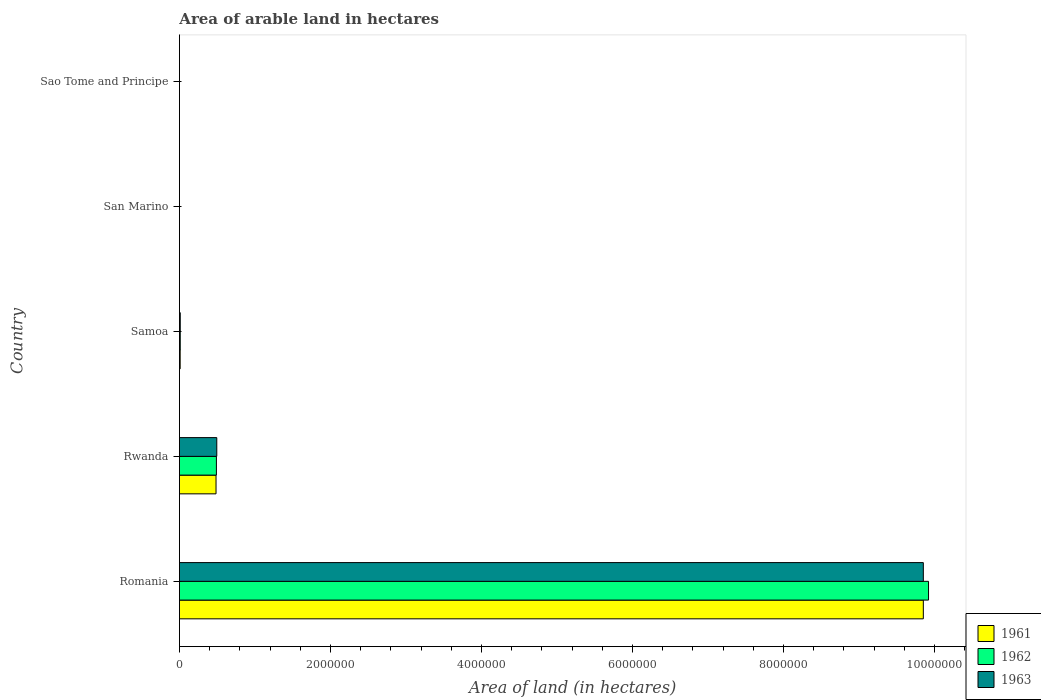Are the number of bars per tick equal to the number of legend labels?
Provide a succinct answer. Yes. How many bars are there on the 3rd tick from the top?
Your answer should be very brief. 3. What is the label of the 3rd group of bars from the top?
Your answer should be very brief. Samoa. What is the total arable land in 1963 in Rwanda?
Make the answer very short. 4.95e+05. Across all countries, what is the maximum total arable land in 1961?
Offer a terse response. 9.85e+06. In which country was the total arable land in 1962 maximum?
Provide a short and direct response. Romania. In which country was the total arable land in 1963 minimum?
Your answer should be very brief. San Marino. What is the total total arable land in 1962 in the graph?
Your response must be concise. 1.04e+07. What is the difference between the total arable land in 1962 in Romania and that in Rwanda?
Offer a terse response. 9.43e+06. What is the difference between the total arable land in 1962 in Romania and the total arable land in 1963 in Rwanda?
Offer a very short reply. 9.43e+06. What is the average total arable land in 1963 per country?
Keep it short and to the point. 2.07e+06. What is the ratio of the total arable land in 1962 in Samoa to that in Sao Tome and Principe?
Offer a terse response. 11. What is the difference between the highest and the second highest total arable land in 1961?
Provide a short and direct response. 9.37e+06. What is the difference between the highest and the lowest total arable land in 1961?
Provide a short and direct response. 9.85e+06. In how many countries, is the total arable land in 1962 greater than the average total arable land in 1962 taken over all countries?
Give a very brief answer. 1. Is the sum of the total arable land in 1962 in Romania and Samoa greater than the maximum total arable land in 1961 across all countries?
Offer a very short reply. Yes. What does the 3rd bar from the bottom in Samoa represents?
Your answer should be compact. 1963. Are all the bars in the graph horizontal?
Your response must be concise. Yes. What is the difference between two consecutive major ticks on the X-axis?
Ensure brevity in your answer.  2.00e+06. Are the values on the major ticks of X-axis written in scientific E-notation?
Your answer should be very brief. No. Does the graph contain any zero values?
Offer a terse response. No. Where does the legend appear in the graph?
Provide a succinct answer. Bottom right. How many legend labels are there?
Your answer should be very brief. 3. What is the title of the graph?
Offer a very short reply. Area of arable land in hectares. Does "2002" appear as one of the legend labels in the graph?
Give a very brief answer. No. What is the label or title of the X-axis?
Make the answer very short. Area of land (in hectares). What is the label or title of the Y-axis?
Your response must be concise. Country. What is the Area of land (in hectares) in 1961 in Romania?
Keep it short and to the point. 9.85e+06. What is the Area of land (in hectares) of 1962 in Romania?
Your answer should be very brief. 9.92e+06. What is the Area of land (in hectares) in 1963 in Romania?
Your answer should be compact. 9.85e+06. What is the Area of land (in hectares) in 1961 in Rwanda?
Offer a very short reply. 4.85e+05. What is the Area of land (in hectares) in 1963 in Rwanda?
Your answer should be compact. 4.95e+05. What is the Area of land (in hectares) of 1962 in Samoa?
Ensure brevity in your answer.  1.10e+04. What is the Area of land (in hectares) in 1963 in Samoa?
Give a very brief answer. 1.10e+04. What is the Area of land (in hectares) of 1962 in San Marino?
Keep it short and to the point. 1000. What is the Area of land (in hectares) of 1963 in San Marino?
Offer a terse response. 1000. What is the Area of land (in hectares) in 1961 in Sao Tome and Principe?
Give a very brief answer. 1000. Across all countries, what is the maximum Area of land (in hectares) of 1961?
Offer a terse response. 9.85e+06. Across all countries, what is the maximum Area of land (in hectares) of 1962?
Your response must be concise. 9.92e+06. Across all countries, what is the maximum Area of land (in hectares) of 1963?
Offer a terse response. 9.85e+06. Across all countries, what is the minimum Area of land (in hectares) of 1961?
Provide a succinct answer. 1000. Across all countries, what is the minimum Area of land (in hectares) in 1963?
Offer a very short reply. 1000. What is the total Area of land (in hectares) in 1961 in the graph?
Your answer should be very brief. 1.04e+07. What is the total Area of land (in hectares) of 1962 in the graph?
Offer a very short reply. 1.04e+07. What is the total Area of land (in hectares) of 1963 in the graph?
Provide a succinct answer. 1.04e+07. What is the difference between the Area of land (in hectares) in 1961 in Romania and that in Rwanda?
Provide a succinct answer. 9.37e+06. What is the difference between the Area of land (in hectares) of 1962 in Romania and that in Rwanda?
Offer a very short reply. 9.43e+06. What is the difference between the Area of land (in hectares) in 1963 in Romania and that in Rwanda?
Offer a terse response. 9.36e+06. What is the difference between the Area of land (in hectares) of 1961 in Romania and that in Samoa?
Ensure brevity in your answer.  9.84e+06. What is the difference between the Area of land (in hectares) in 1962 in Romania and that in Samoa?
Your response must be concise. 9.91e+06. What is the difference between the Area of land (in hectares) of 1963 in Romania and that in Samoa?
Provide a short and direct response. 9.84e+06. What is the difference between the Area of land (in hectares) in 1961 in Romania and that in San Marino?
Offer a very short reply. 9.85e+06. What is the difference between the Area of land (in hectares) in 1962 in Romania and that in San Marino?
Give a very brief answer. 9.92e+06. What is the difference between the Area of land (in hectares) in 1963 in Romania and that in San Marino?
Give a very brief answer. 9.85e+06. What is the difference between the Area of land (in hectares) in 1961 in Romania and that in Sao Tome and Principe?
Provide a short and direct response. 9.85e+06. What is the difference between the Area of land (in hectares) in 1962 in Romania and that in Sao Tome and Principe?
Offer a terse response. 9.92e+06. What is the difference between the Area of land (in hectares) in 1963 in Romania and that in Sao Tome and Principe?
Provide a succinct answer. 9.85e+06. What is the difference between the Area of land (in hectares) of 1961 in Rwanda and that in Samoa?
Your answer should be compact. 4.75e+05. What is the difference between the Area of land (in hectares) in 1962 in Rwanda and that in Samoa?
Your answer should be compact. 4.79e+05. What is the difference between the Area of land (in hectares) of 1963 in Rwanda and that in Samoa?
Provide a short and direct response. 4.84e+05. What is the difference between the Area of land (in hectares) in 1961 in Rwanda and that in San Marino?
Your answer should be very brief. 4.84e+05. What is the difference between the Area of land (in hectares) of 1962 in Rwanda and that in San Marino?
Your answer should be very brief. 4.89e+05. What is the difference between the Area of land (in hectares) of 1963 in Rwanda and that in San Marino?
Your answer should be very brief. 4.94e+05. What is the difference between the Area of land (in hectares) in 1961 in Rwanda and that in Sao Tome and Principe?
Offer a terse response. 4.84e+05. What is the difference between the Area of land (in hectares) in 1962 in Rwanda and that in Sao Tome and Principe?
Offer a very short reply. 4.89e+05. What is the difference between the Area of land (in hectares) in 1963 in Rwanda and that in Sao Tome and Principe?
Your answer should be very brief. 4.94e+05. What is the difference between the Area of land (in hectares) in 1961 in Samoa and that in San Marino?
Your answer should be compact. 9000. What is the difference between the Area of land (in hectares) in 1962 in Samoa and that in San Marino?
Ensure brevity in your answer.  10000. What is the difference between the Area of land (in hectares) in 1963 in Samoa and that in San Marino?
Ensure brevity in your answer.  10000. What is the difference between the Area of land (in hectares) of 1961 in Samoa and that in Sao Tome and Principe?
Give a very brief answer. 9000. What is the difference between the Area of land (in hectares) in 1962 in Samoa and that in Sao Tome and Principe?
Keep it short and to the point. 10000. What is the difference between the Area of land (in hectares) of 1963 in Samoa and that in Sao Tome and Principe?
Offer a terse response. 10000. What is the difference between the Area of land (in hectares) of 1961 in San Marino and that in Sao Tome and Principe?
Make the answer very short. 0. What is the difference between the Area of land (in hectares) in 1962 in San Marino and that in Sao Tome and Principe?
Offer a very short reply. 0. What is the difference between the Area of land (in hectares) of 1963 in San Marino and that in Sao Tome and Principe?
Your answer should be compact. 0. What is the difference between the Area of land (in hectares) in 1961 in Romania and the Area of land (in hectares) in 1962 in Rwanda?
Offer a very short reply. 9.36e+06. What is the difference between the Area of land (in hectares) in 1961 in Romania and the Area of land (in hectares) in 1963 in Rwanda?
Your answer should be compact. 9.36e+06. What is the difference between the Area of land (in hectares) of 1962 in Romania and the Area of land (in hectares) of 1963 in Rwanda?
Your answer should be very brief. 9.43e+06. What is the difference between the Area of land (in hectares) of 1961 in Romania and the Area of land (in hectares) of 1962 in Samoa?
Give a very brief answer. 9.84e+06. What is the difference between the Area of land (in hectares) in 1961 in Romania and the Area of land (in hectares) in 1963 in Samoa?
Offer a very short reply. 9.84e+06. What is the difference between the Area of land (in hectares) in 1962 in Romania and the Area of land (in hectares) in 1963 in Samoa?
Your answer should be very brief. 9.91e+06. What is the difference between the Area of land (in hectares) of 1961 in Romania and the Area of land (in hectares) of 1962 in San Marino?
Ensure brevity in your answer.  9.85e+06. What is the difference between the Area of land (in hectares) in 1961 in Romania and the Area of land (in hectares) in 1963 in San Marino?
Your answer should be very brief. 9.85e+06. What is the difference between the Area of land (in hectares) in 1962 in Romania and the Area of land (in hectares) in 1963 in San Marino?
Provide a short and direct response. 9.92e+06. What is the difference between the Area of land (in hectares) in 1961 in Romania and the Area of land (in hectares) in 1962 in Sao Tome and Principe?
Keep it short and to the point. 9.85e+06. What is the difference between the Area of land (in hectares) in 1961 in Romania and the Area of land (in hectares) in 1963 in Sao Tome and Principe?
Provide a short and direct response. 9.85e+06. What is the difference between the Area of land (in hectares) in 1962 in Romania and the Area of land (in hectares) in 1963 in Sao Tome and Principe?
Your answer should be very brief. 9.92e+06. What is the difference between the Area of land (in hectares) in 1961 in Rwanda and the Area of land (in hectares) in 1962 in Samoa?
Give a very brief answer. 4.74e+05. What is the difference between the Area of land (in hectares) in 1961 in Rwanda and the Area of land (in hectares) in 1963 in Samoa?
Provide a succinct answer. 4.74e+05. What is the difference between the Area of land (in hectares) of 1962 in Rwanda and the Area of land (in hectares) of 1963 in Samoa?
Offer a very short reply. 4.79e+05. What is the difference between the Area of land (in hectares) of 1961 in Rwanda and the Area of land (in hectares) of 1962 in San Marino?
Give a very brief answer. 4.84e+05. What is the difference between the Area of land (in hectares) in 1961 in Rwanda and the Area of land (in hectares) in 1963 in San Marino?
Your response must be concise. 4.84e+05. What is the difference between the Area of land (in hectares) in 1962 in Rwanda and the Area of land (in hectares) in 1963 in San Marino?
Ensure brevity in your answer.  4.89e+05. What is the difference between the Area of land (in hectares) of 1961 in Rwanda and the Area of land (in hectares) of 1962 in Sao Tome and Principe?
Offer a terse response. 4.84e+05. What is the difference between the Area of land (in hectares) in 1961 in Rwanda and the Area of land (in hectares) in 1963 in Sao Tome and Principe?
Your answer should be very brief. 4.84e+05. What is the difference between the Area of land (in hectares) of 1962 in Rwanda and the Area of land (in hectares) of 1963 in Sao Tome and Principe?
Keep it short and to the point. 4.89e+05. What is the difference between the Area of land (in hectares) in 1961 in Samoa and the Area of land (in hectares) in 1962 in San Marino?
Your answer should be very brief. 9000. What is the difference between the Area of land (in hectares) of 1961 in Samoa and the Area of land (in hectares) of 1963 in San Marino?
Provide a short and direct response. 9000. What is the difference between the Area of land (in hectares) in 1961 in Samoa and the Area of land (in hectares) in 1962 in Sao Tome and Principe?
Your answer should be compact. 9000. What is the difference between the Area of land (in hectares) in 1961 in Samoa and the Area of land (in hectares) in 1963 in Sao Tome and Principe?
Your answer should be very brief. 9000. What is the difference between the Area of land (in hectares) of 1962 in Samoa and the Area of land (in hectares) of 1963 in Sao Tome and Principe?
Give a very brief answer. 10000. What is the average Area of land (in hectares) of 1961 per country?
Offer a very short reply. 2.07e+06. What is the average Area of land (in hectares) of 1962 per country?
Your answer should be compact. 2.08e+06. What is the average Area of land (in hectares) in 1963 per country?
Offer a terse response. 2.07e+06. What is the difference between the Area of land (in hectares) in 1961 and Area of land (in hectares) in 1962 in Romania?
Offer a very short reply. -6.90e+04. What is the difference between the Area of land (in hectares) in 1962 and Area of land (in hectares) in 1963 in Romania?
Provide a short and direct response. 6.90e+04. What is the difference between the Area of land (in hectares) of 1961 and Area of land (in hectares) of 1962 in Rwanda?
Provide a short and direct response. -5000. What is the difference between the Area of land (in hectares) of 1962 and Area of land (in hectares) of 1963 in Rwanda?
Make the answer very short. -5000. What is the difference between the Area of land (in hectares) in 1961 and Area of land (in hectares) in 1962 in Samoa?
Give a very brief answer. -1000. What is the difference between the Area of land (in hectares) in 1961 and Area of land (in hectares) in 1963 in Samoa?
Provide a succinct answer. -1000. What is the difference between the Area of land (in hectares) of 1961 and Area of land (in hectares) of 1962 in San Marino?
Provide a short and direct response. 0. What is the difference between the Area of land (in hectares) of 1962 and Area of land (in hectares) of 1963 in San Marino?
Give a very brief answer. 0. What is the difference between the Area of land (in hectares) in 1961 and Area of land (in hectares) in 1962 in Sao Tome and Principe?
Provide a short and direct response. 0. What is the difference between the Area of land (in hectares) in 1961 and Area of land (in hectares) in 1963 in Sao Tome and Principe?
Provide a succinct answer. 0. What is the difference between the Area of land (in hectares) in 1962 and Area of land (in hectares) in 1963 in Sao Tome and Principe?
Your response must be concise. 0. What is the ratio of the Area of land (in hectares) of 1961 in Romania to that in Rwanda?
Give a very brief answer. 20.32. What is the ratio of the Area of land (in hectares) of 1962 in Romania to that in Rwanda?
Your answer should be compact. 20.25. What is the ratio of the Area of land (in hectares) of 1963 in Romania to that in Rwanda?
Your answer should be very brief. 19.91. What is the ratio of the Area of land (in hectares) in 1961 in Romania to that in Samoa?
Your answer should be compact. 985.3. What is the ratio of the Area of land (in hectares) of 1962 in Romania to that in Samoa?
Your response must be concise. 902. What is the ratio of the Area of land (in hectares) in 1963 in Romania to that in Samoa?
Provide a succinct answer. 895.73. What is the ratio of the Area of land (in hectares) of 1961 in Romania to that in San Marino?
Ensure brevity in your answer.  9853. What is the ratio of the Area of land (in hectares) of 1962 in Romania to that in San Marino?
Your response must be concise. 9922. What is the ratio of the Area of land (in hectares) in 1963 in Romania to that in San Marino?
Keep it short and to the point. 9853. What is the ratio of the Area of land (in hectares) of 1961 in Romania to that in Sao Tome and Principe?
Ensure brevity in your answer.  9853. What is the ratio of the Area of land (in hectares) in 1962 in Romania to that in Sao Tome and Principe?
Keep it short and to the point. 9922. What is the ratio of the Area of land (in hectares) of 1963 in Romania to that in Sao Tome and Principe?
Ensure brevity in your answer.  9853. What is the ratio of the Area of land (in hectares) in 1961 in Rwanda to that in Samoa?
Make the answer very short. 48.5. What is the ratio of the Area of land (in hectares) of 1962 in Rwanda to that in Samoa?
Give a very brief answer. 44.55. What is the ratio of the Area of land (in hectares) of 1963 in Rwanda to that in Samoa?
Your answer should be compact. 45. What is the ratio of the Area of land (in hectares) of 1961 in Rwanda to that in San Marino?
Keep it short and to the point. 485. What is the ratio of the Area of land (in hectares) of 1962 in Rwanda to that in San Marino?
Ensure brevity in your answer.  490. What is the ratio of the Area of land (in hectares) in 1963 in Rwanda to that in San Marino?
Keep it short and to the point. 495. What is the ratio of the Area of land (in hectares) of 1961 in Rwanda to that in Sao Tome and Principe?
Offer a very short reply. 485. What is the ratio of the Area of land (in hectares) of 1962 in Rwanda to that in Sao Tome and Principe?
Provide a short and direct response. 490. What is the ratio of the Area of land (in hectares) in 1963 in Rwanda to that in Sao Tome and Principe?
Ensure brevity in your answer.  495. What is the ratio of the Area of land (in hectares) in 1963 in Samoa to that in San Marino?
Provide a short and direct response. 11. What is the ratio of the Area of land (in hectares) of 1961 in Samoa to that in Sao Tome and Principe?
Your answer should be very brief. 10. What is the ratio of the Area of land (in hectares) in 1962 in Samoa to that in Sao Tome and Principe?
Offer a very short reply. 11. What is the ratio of the Area of land (in hectares) of 1963 in Samoa to that in Sao Tome and Principe?
Keep it short and to the point. 11. What is the ratio of the Area of land (in hectares) of 1961 in San Marino to that in Sao Tome and Principe?
Give a very brief answer. 1. What is the ratio of the Area of land (in hectares) in 1962 in San Marino to that in Sao Tome and Principe?
Your answer should be compact. 1. What is the ratio of the Area of land (in hectares) of 1963 in San Marino to that in Sao Tome and Principe?
Offer a terse response. 1. What is the difference between the highest and the second highest Area of land (in hectares) of 1961?
Offer a terse response. 9.37e+06. What is the difference between the highest and the second highest Area of land (in hectares) in 1962?
Provide a succinct answer. 9.43e+06. What is the difference between the highest and the second highest Area of land (in hectares) in 1963?
Keep it short and to the point. 9.36e+06. What is the difference between the highest and the lowest Area of land (in hectares) in 1961?
Make the answer very short. 9.85e+06. What is the difference between the highest and the lowest Area of land (in hectares) in 1962?
Your answer should be compact. 9.92e+06. What is the difference between the highest and the lowest Area of land (in hectares) of 1963?
Keep it short and to the point. 9.85e+06. 